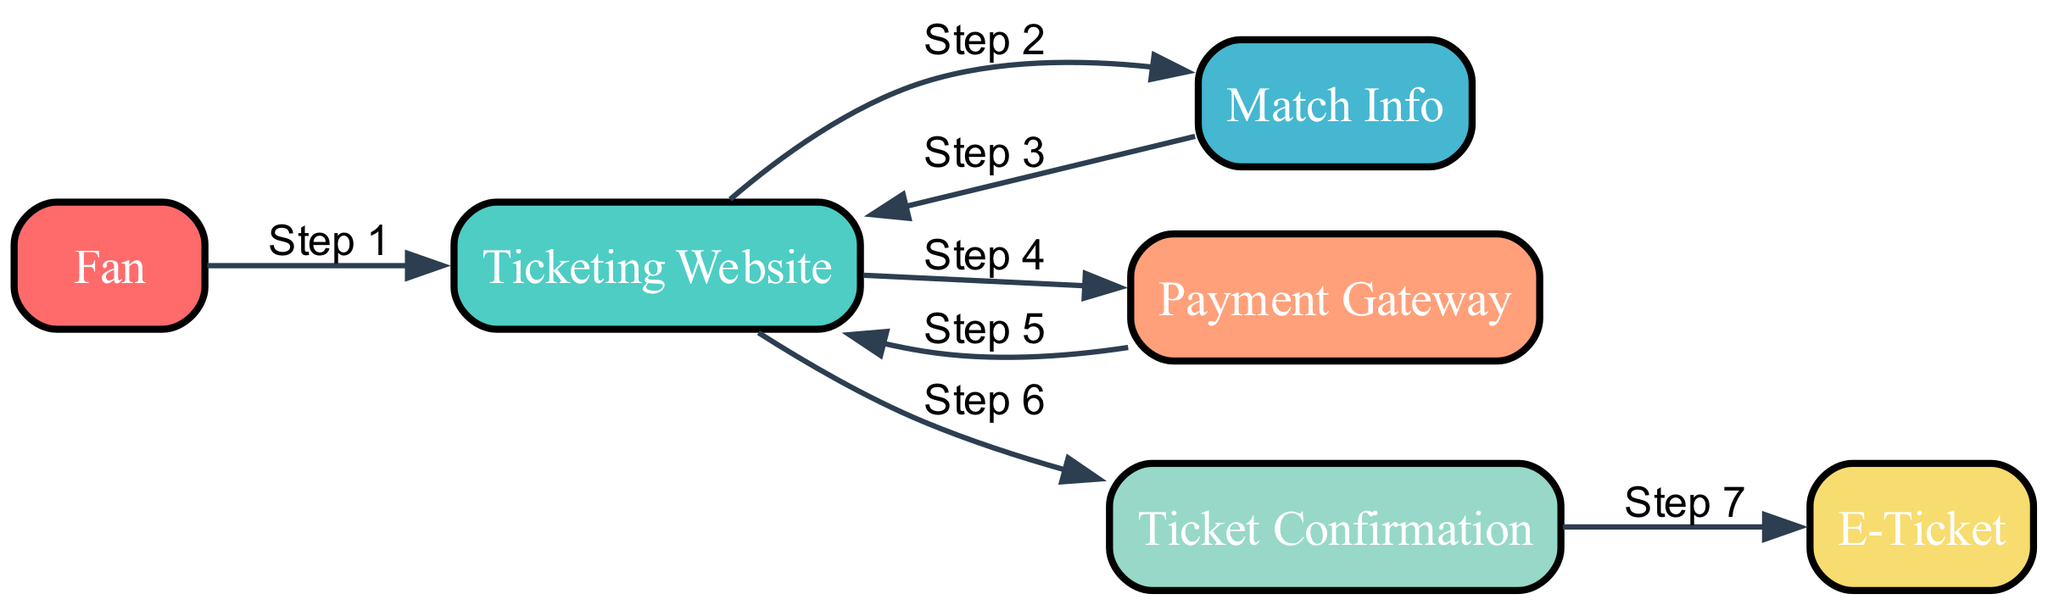What is the first node in the diagram? The first node in the flow represents the 'Fan', as this is where the purchasing process begins.
Answer: Fan How many total nodes are present in the diagram? There are a total of 6 nodes in the diagram: Fan, Ticketing Website, Match Info, Payment Gateway, Ticket Confirmation, and E-Ticket.
Answer: 6 What is the final step in the ticket purchasing flow? The final step in the flow is the fan receiving the 'E-Ticket', which indicates that the purchase was successful and allows entry to the match.
Answer: E-Ticket What action does the 'Fan' take after browsing on the 'Ticketing Website'? After browsing on the 'Ticketing Website', the 'Fan' proceeds to make a payment through the 'Payment Gateway' to complete the purchase process.
Answer: Payment Gateway Which node is directly connected to 'Ticket Confirmation'? The node that is directly connected to 'Ticket Confirmation' is 'Ticketing Website', indicating that the confirmation is sent back after the payment is processed.
Answer: Ticketing Website How many steps are involved from the 'Fan' to the 'E-Ticket'? There are a total of 7 steps involved from the 'Fan' to the 'E-Ticket', including interactions with the Ticketing Website, Match Info, Payment Gateway, and lastly receiving the E-Ticket.
Answer: 7 What interaction happens after 'Payment Gateway'? After the 'Payment Gateway', the 'Ticketing Website' sends a 'Ticket Confirmation' back to the 'Fan', confirming the successful transaction.
Answer: Ticket Confirmation Which node involves payment processing? The node that specifically involves payment processing is the 'Payment Gateway', which ensures that transactions are conducted securely and efficiently.
Answer: Payment Gateway What is the connection between 'Match Info' and 'Ticketing Website'? The connection between 'Match Info' and 'Ticketing Website' is that the fan obtains match details before making a ticket purchase, thus aiding in decision-making.
Answer: Ticketing Website 